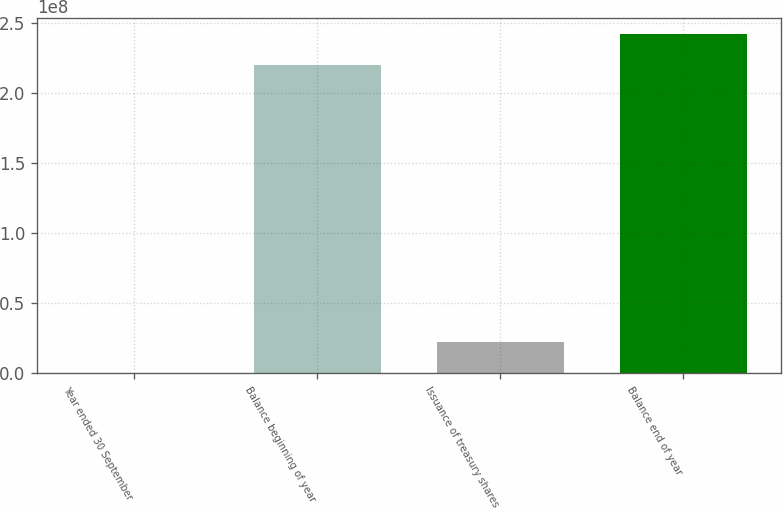<chart> <loc_0><loc_0><loc_500><loc_500><bar_chart><fcel>Year ended 30 September<fcel>Balance beginning of year<fcel>Issuance of treasury shares<fcel>Balance end of year<nl><fcel>2019<fcel>2.19515e+08<fcel>2.20433e+07<fcel>2.41557e+08<nl></chart> 